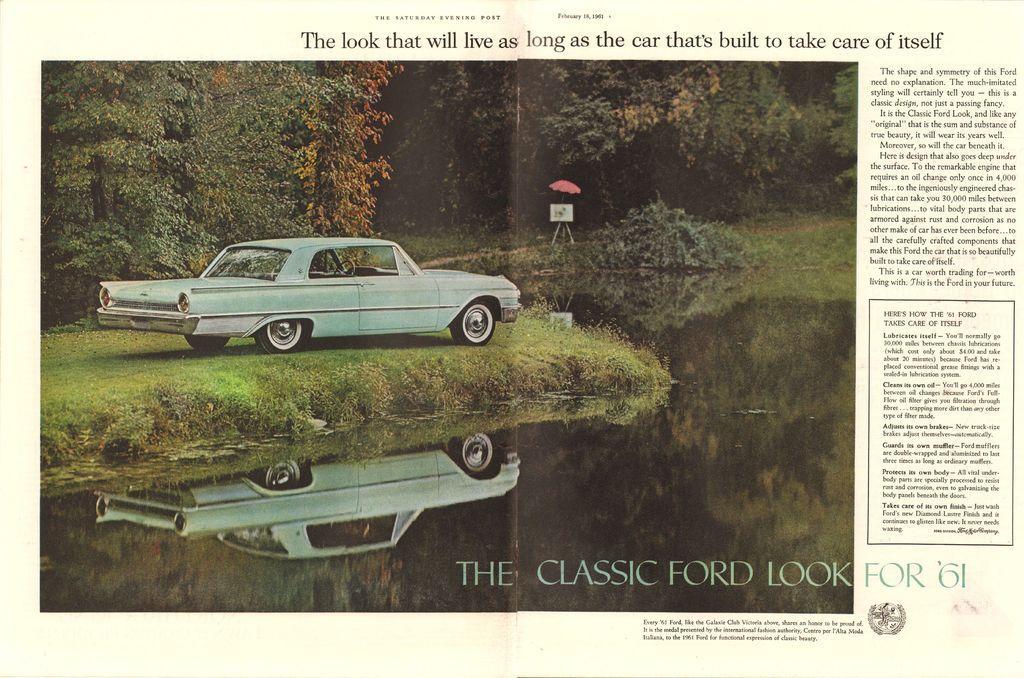How would you summarize this image in a sentence or two? In this picture I can see an article. There is a car, grass, water, reflections, umbrella, board, plants and trees. Something is written in the article.   